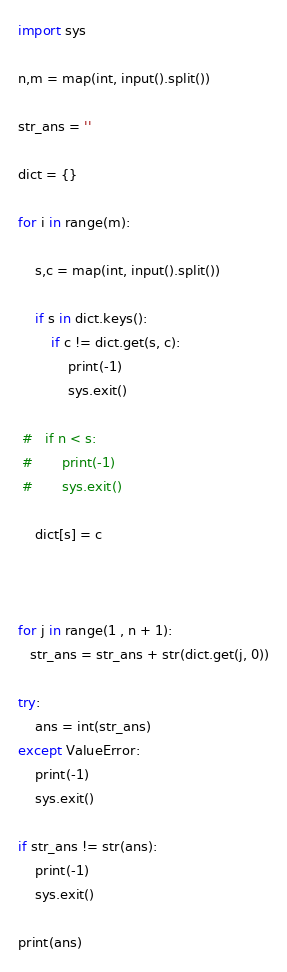Convert code to text. <code><loc_0><loc_0><loc_500><loc_500><_Python_>import sys

n,m = map(int, input().split())

str_ans = ''

dict = {}

for i in range(m):

    s,c = map(int, input().split())

    if s in dict.keys():
        if c != dict.get(s, c):
            print(-1)
            sys.exit()

 #   if n < s:
 #       print(-1)
 #       sys.exit()

    dict[s] = c 



for j in range(1 , n + 1):
   str_ans = str_ans + str(dict.get(j, 0))

try:
    ans = int(str_ans)
except ValueError:
    print(-1)
    sys.exit()

if str_ans != str(ans):
    print(-1)
    sys.exit()

print(ans)</code> 